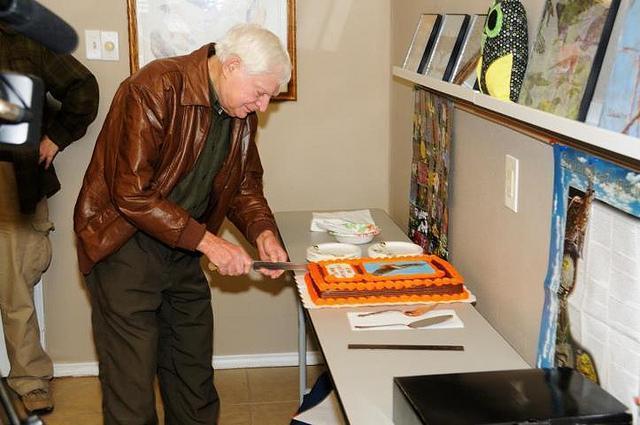How many people are visible?
Give a very brief answer. 2. 